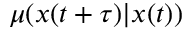Convert formula to latex. <formula><loc_0><loc_0><loc_500><loc_500>\mu ( x ( t + \tau ) | x ( t ) )</formula> 